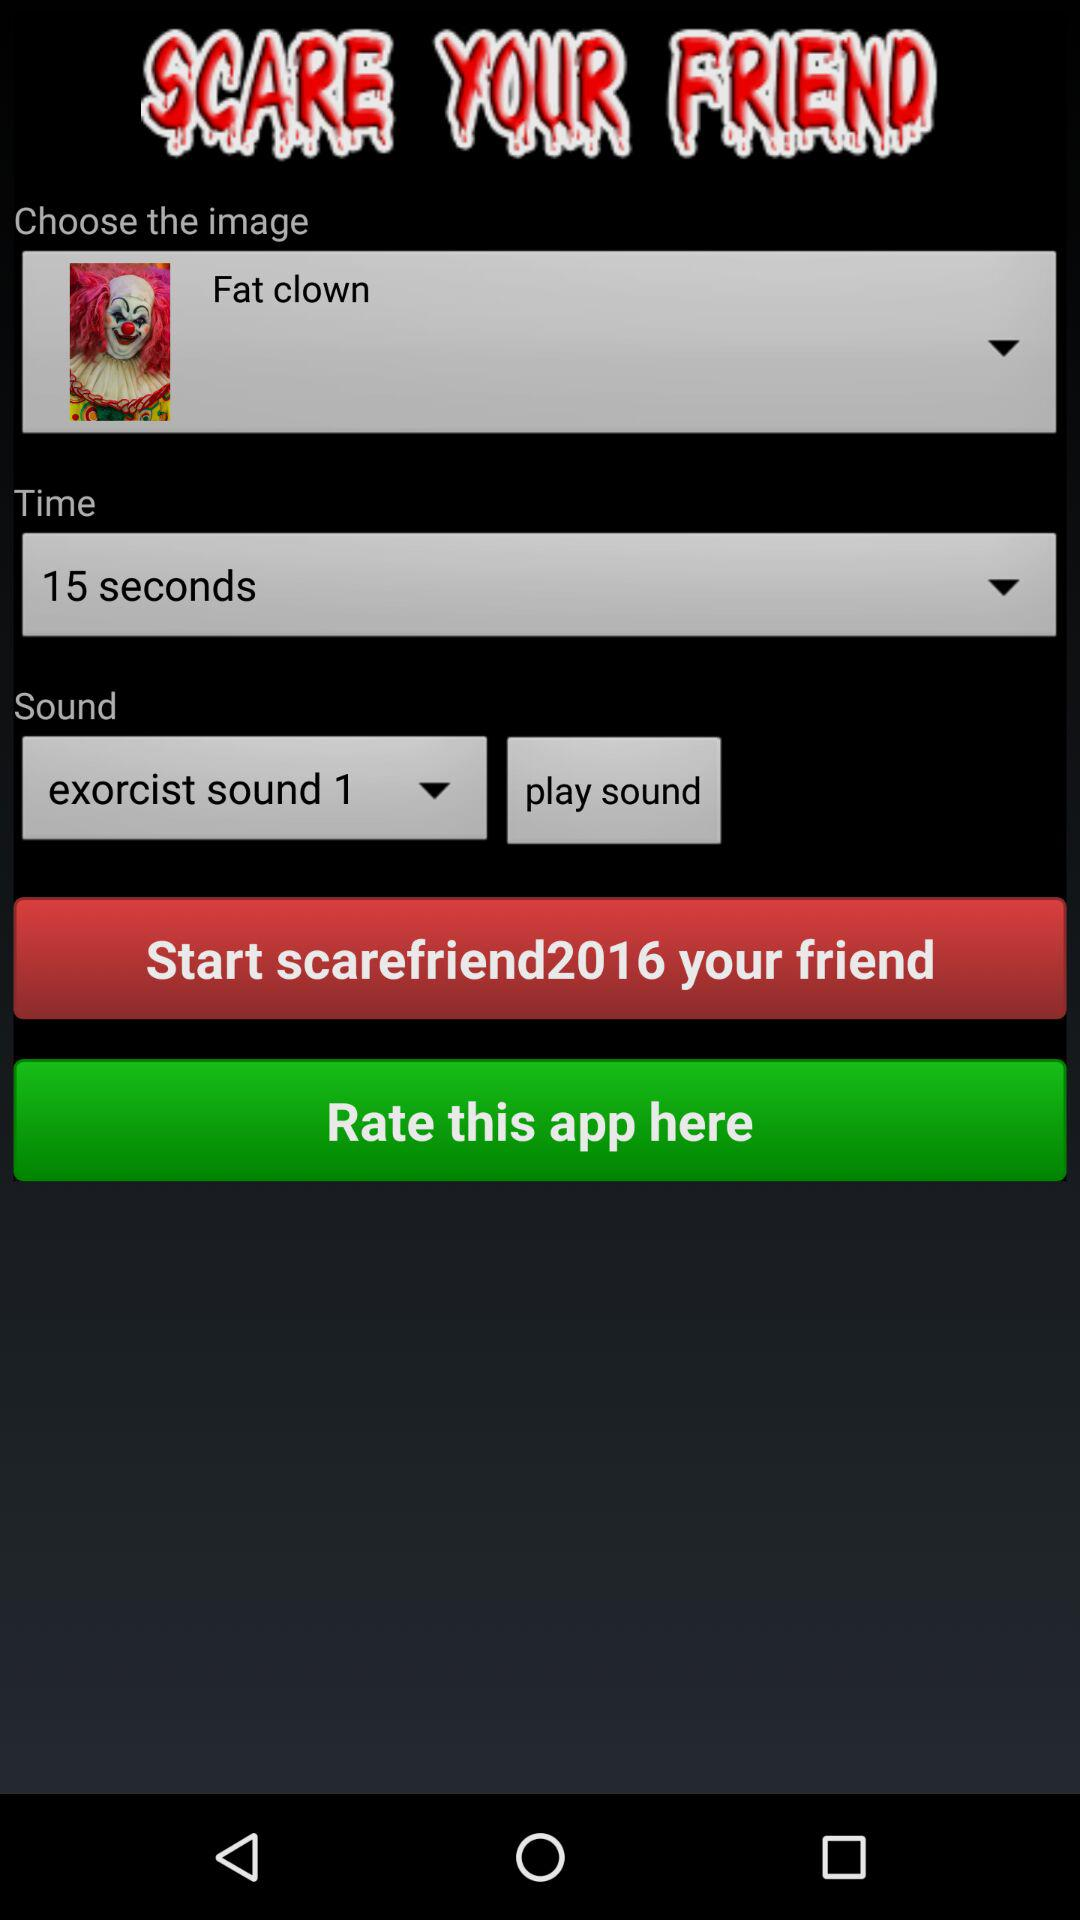What is the application name? The application name is "SCARE YOUR FRIEND". 